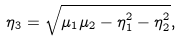Convert formula to latex. <formula><loc_0><loc_0><loc_500><loc_500>\eta _ { 3 } = \sqrt { \mu _ { 1 } \mu _ { 2 } - \eta _ { 1 } ^ { 2 } - \eta _ { 2 } ^ { 2 } } ,</formula> 